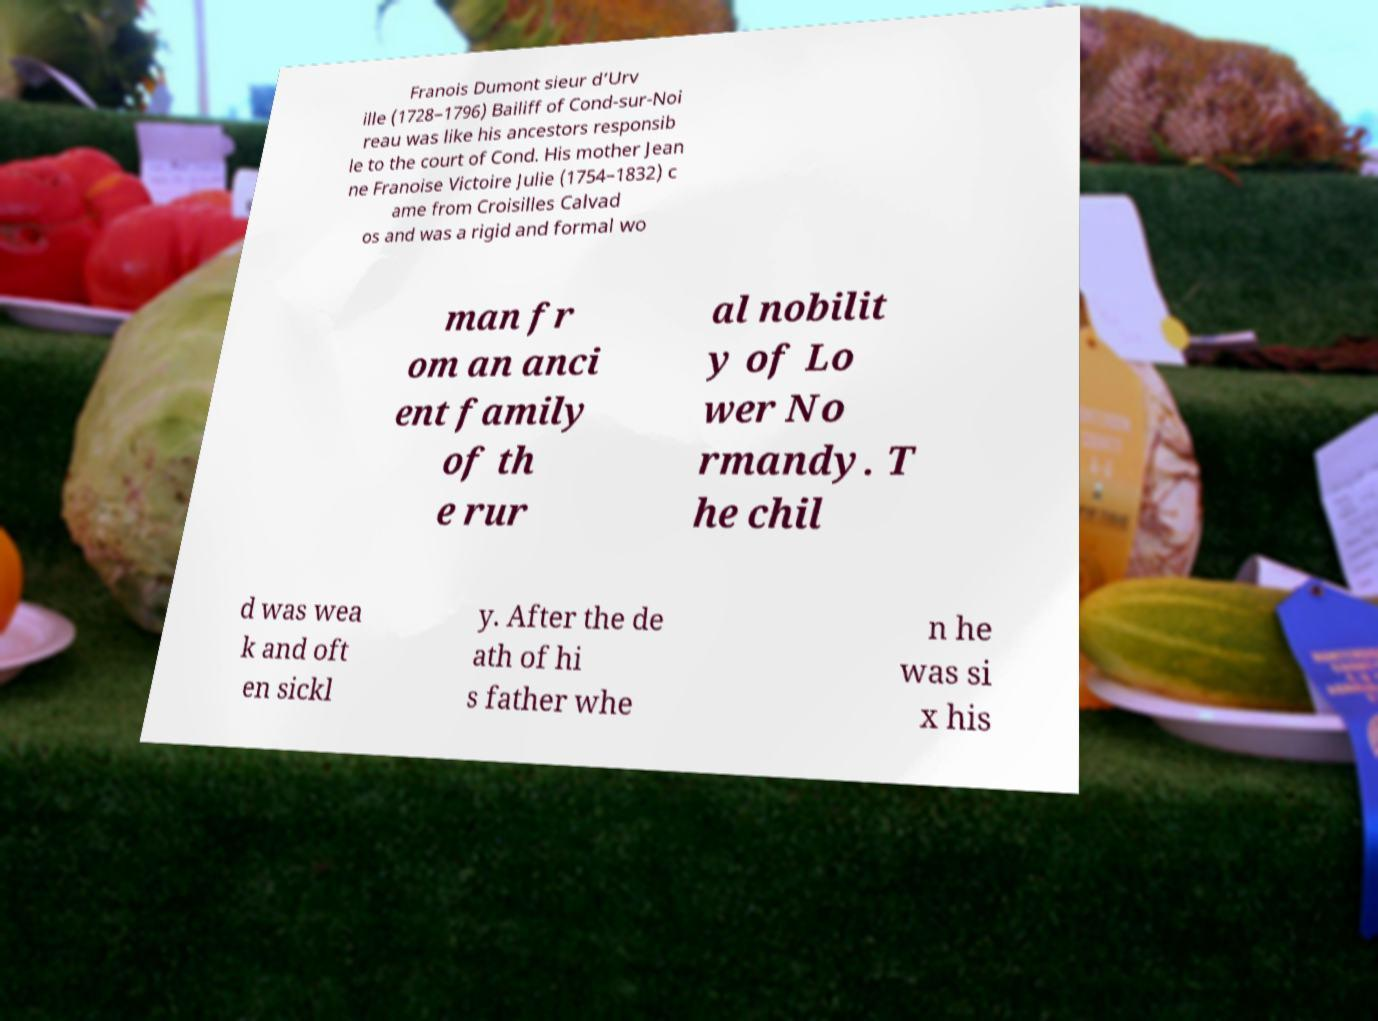Please read and relay the text visible in this image. What does it say? Franois Dumont sieur d’Urv ille (1728–1796) Bailiff of Cond-sur-Noi reau was like his ancestors responsib le to the court of Cond. His mother Jean ne Franoise Victoire Julie (1754–1832) c ame from Croisilles Calvad os and was a rigid and formal wo man fr om an anci ent family of th e rur al nobilit y of Lo wer No rmandy. T he chil d was wea k and oft en sickl y. After the de ath of hi s father whe n he was si x his 